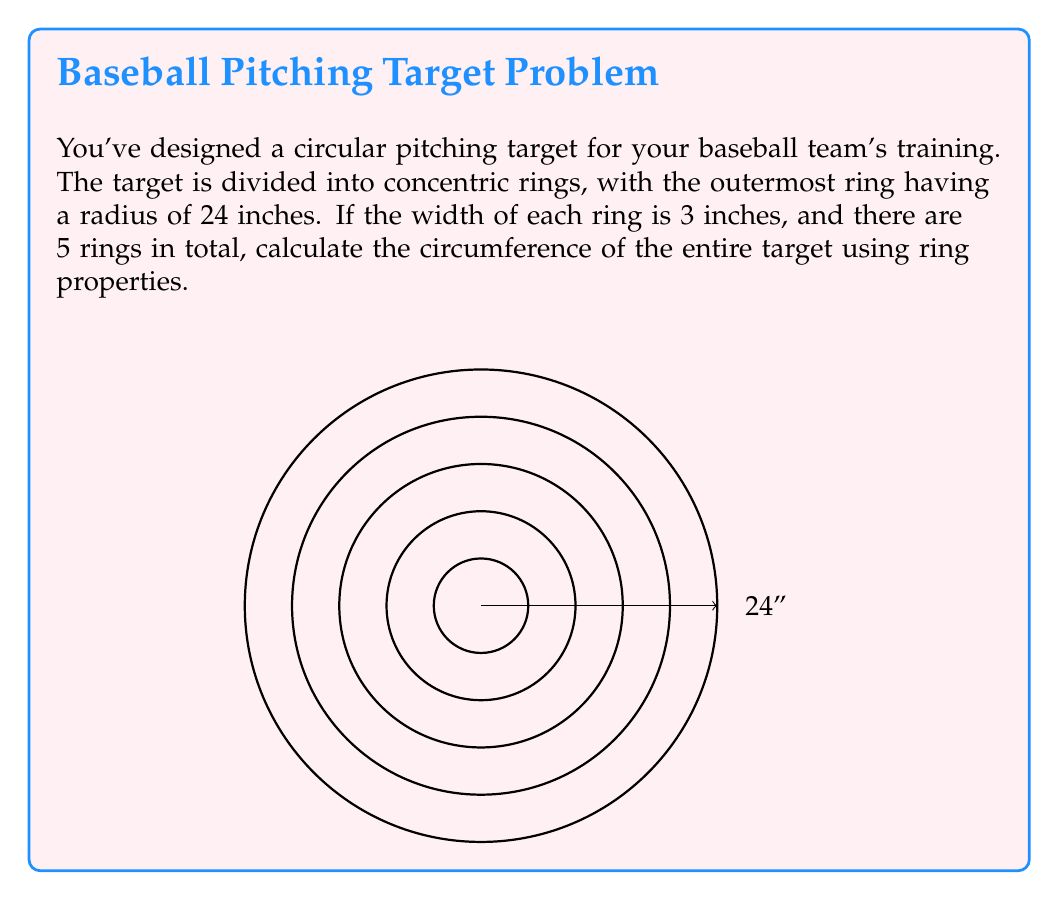Teach me how to tackle this problem. Let's approach this step-by-step using ring properties:

1) First, we need to find the radius of the entire target. We know:
   - There are 5 rings
   - Each ring has a width of 3 inches
   - The outermost ring has a radius of 24 inches

2) The radius of the entire target is the same as the outer radius of the outermost ring, which is 24 inches.

3) In ring theory, we can consider this target as a ring $R$ with the following properties:
   $R = \mathbb{Z}[x]/(x^2 + 1)$, where $\mathbb{Z}[x]$ is the ring of polynomials with integer coefficients.

4) However, for practical purposes, we'll use the standard formula for circumference:
   $C = 2\pi r$, where $r$ is the radius.

5) Substituting our radius:
   $C = 2\pi(24)$

6) Simplifying:
   $C = 48\pi$ inches

7) If we want to approximate this value:
   $C \approx 48 * 3.14159 \approx 150.80$ inches

Therefore, the circumference of the entire target is $48\pi$ inches, or approximately 150.80 inches.
Answer: $48\pi$ inches 